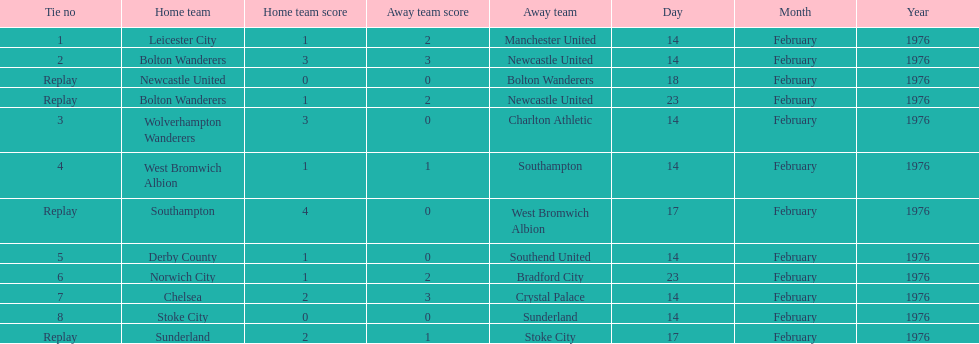Who was the home team in the game on the top of the table? Leicester City. 